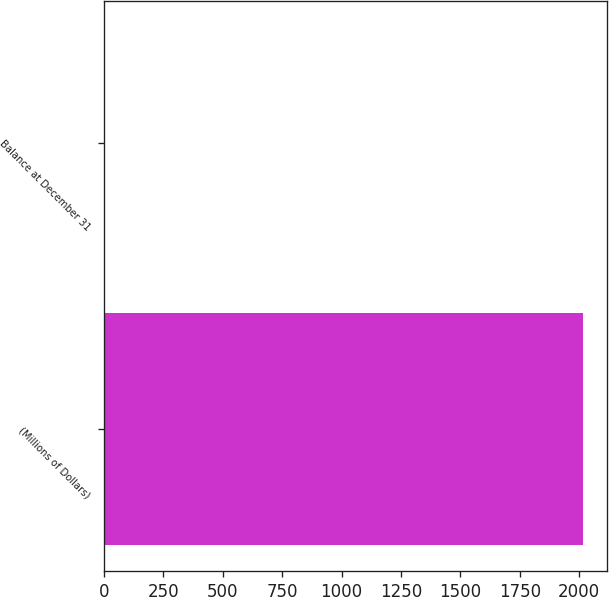Convert chart to OTSL. <chart><loc_0><loc_0><loc_500><loc_500><bar_chart><fcel>(Millions of Dollars)<fcel>Balance at December 31<nl><fcel>2015<fcel>2<nl></chart> 